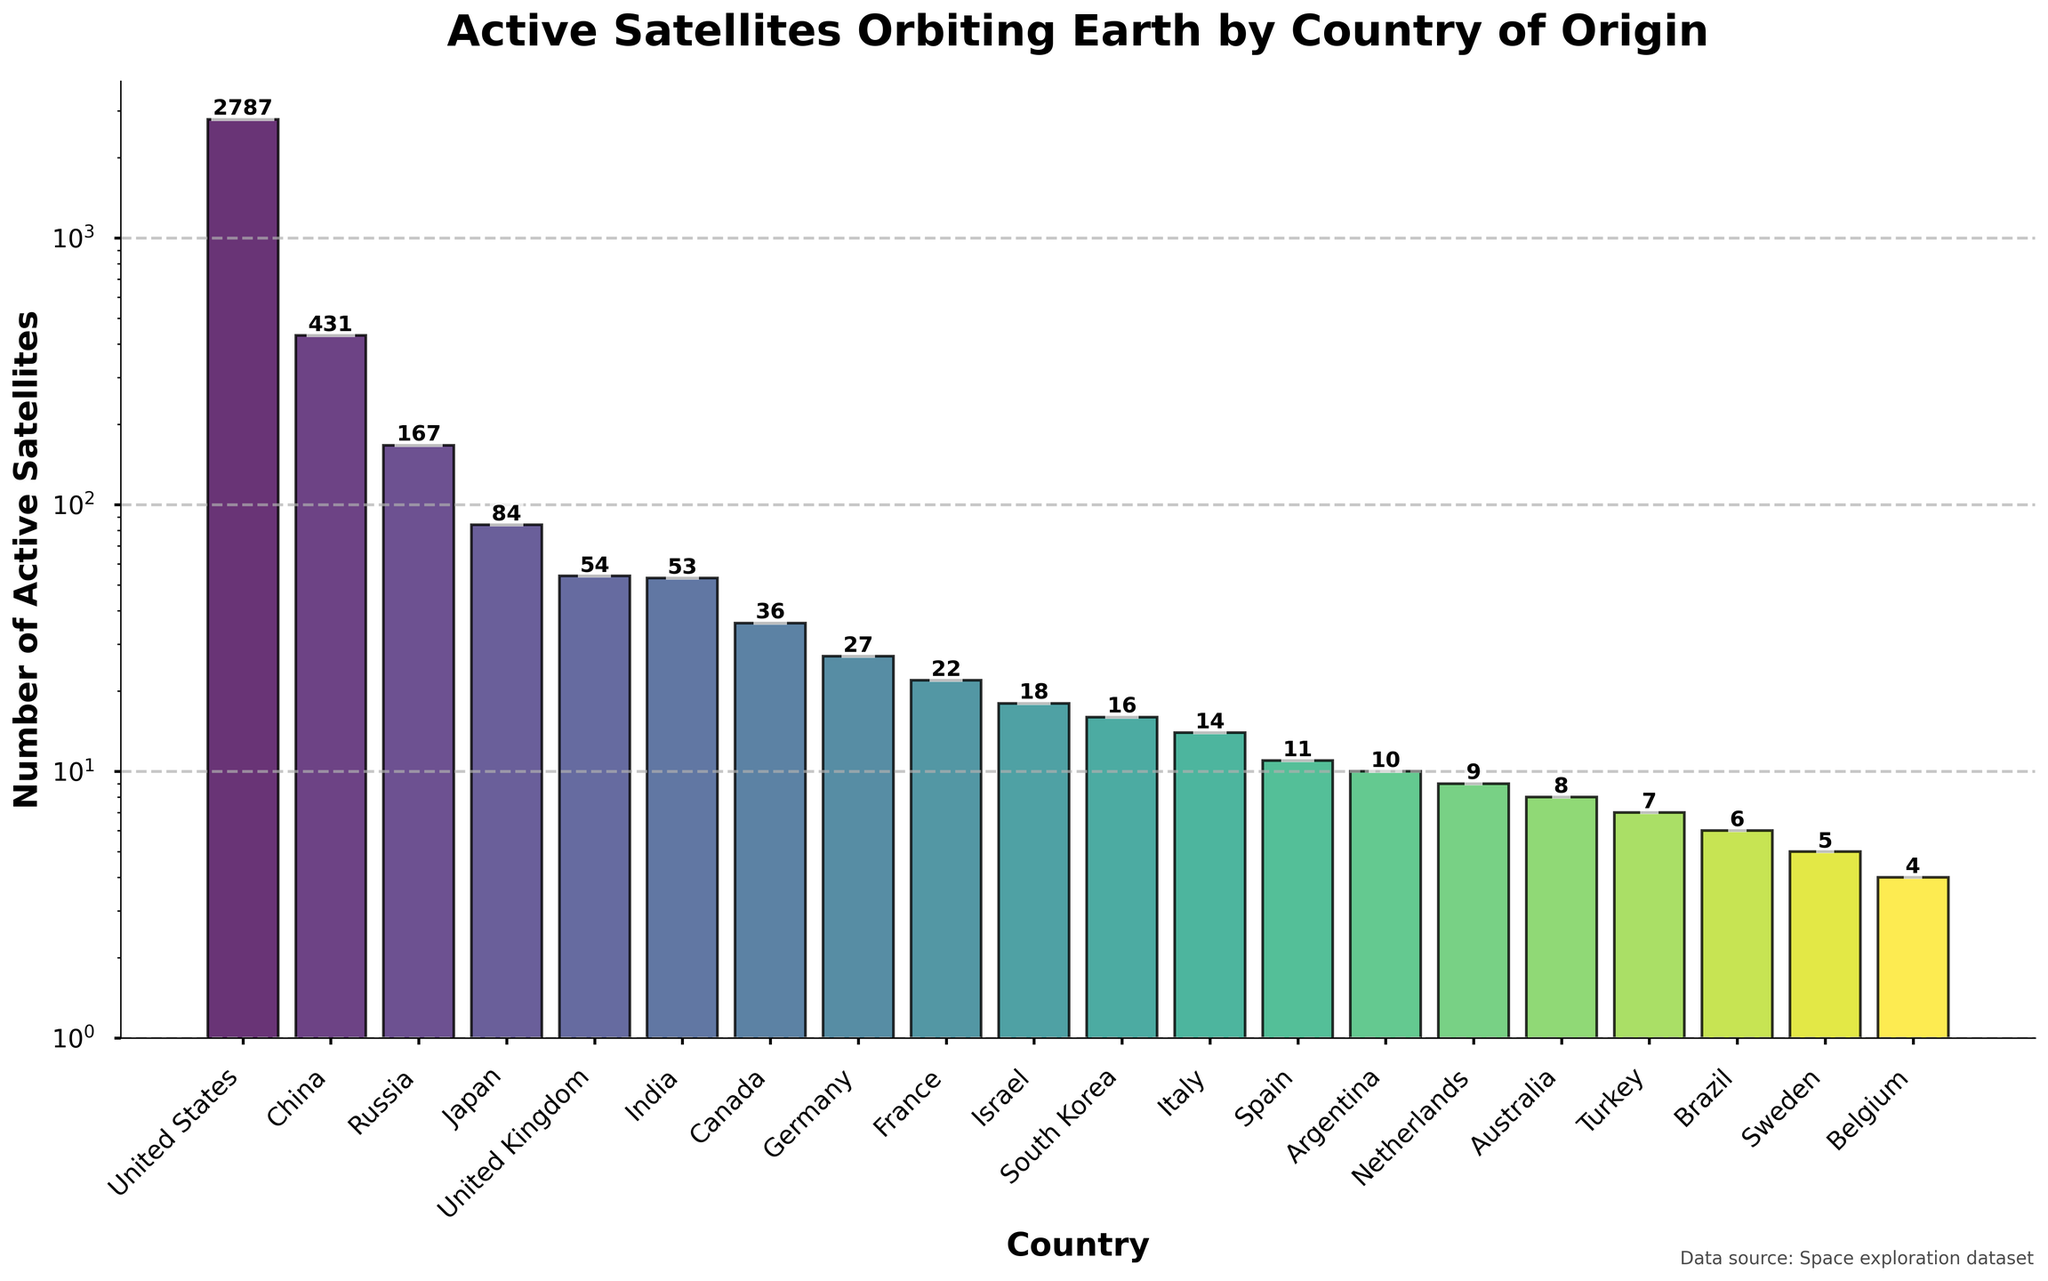Which country has the highest number of active satellites? By looking at the heights of the bars, the United States has the tallest bar, indicating the highest number of active satellites.
Answer: United States How many more active satellites does China have compared to Germany? China has 431 active satellites and Germany has 27 active satellites. The difference is 431 - 27 = 404.
Answer: 404 What is the average number of active satellites for the top three countries? The top three countries are the United States, China, and Russia with 2787, 431, and 167 satellites respectively. The average is (2787 + 431 + 167) / 3 = 1138.33.
Answer: 1138.33 Which countries have fewer than 10 active satellites? By looking at the bars that are shorter and have labels less than 10, the countries are Netherlands, Australia, Turkey, Brazil, Sweden, and Belgium.
Answer: Netherlands, Australia, Turkey, Brazil, Sweden, Belgium What is the combined total of active satellites for United Kingdom, India, and Canada? The United Kingdom has 54, India has 53, and Canada has 36 active satellites. The combined total is 54 + 53 + 36 = 143.
Answer: 143 How does the number of satellites for Japan compare to France? Japan has 84 active satellites and France has 22. Japan has more satellites than France.
Answer: Japan Which country has the smallest number of active satellites and how many? The smallest bar corresponds to Belgium which has 4 active satellites.
Answer: Belgium, 4 Are there more active satellites from Israel or South Korea? By comparing the heights of their bars, Israel has 18 active satellites and South Korea has 16. Israel has more.
Answer: Israel What's the median number of active satellites among the given countries? Listing the active satellites in ascending order: 4, 5, 6, 7, 8, 9, 10, 11, 14, 16, 18, 22, 27, 36, 53, 54, 84, 167, 431, 2787. With an even number of countries (20), the median is the average of the 10th and 11th values: (16 + 18) / 2 = 17.
Answer: 17 Out of France, Israel, and Italy, which country has the greatest number of active satellites? France has 22, Israel has 18, and Italy has 14 active satellites. France has the greatest number.
Answer: France 